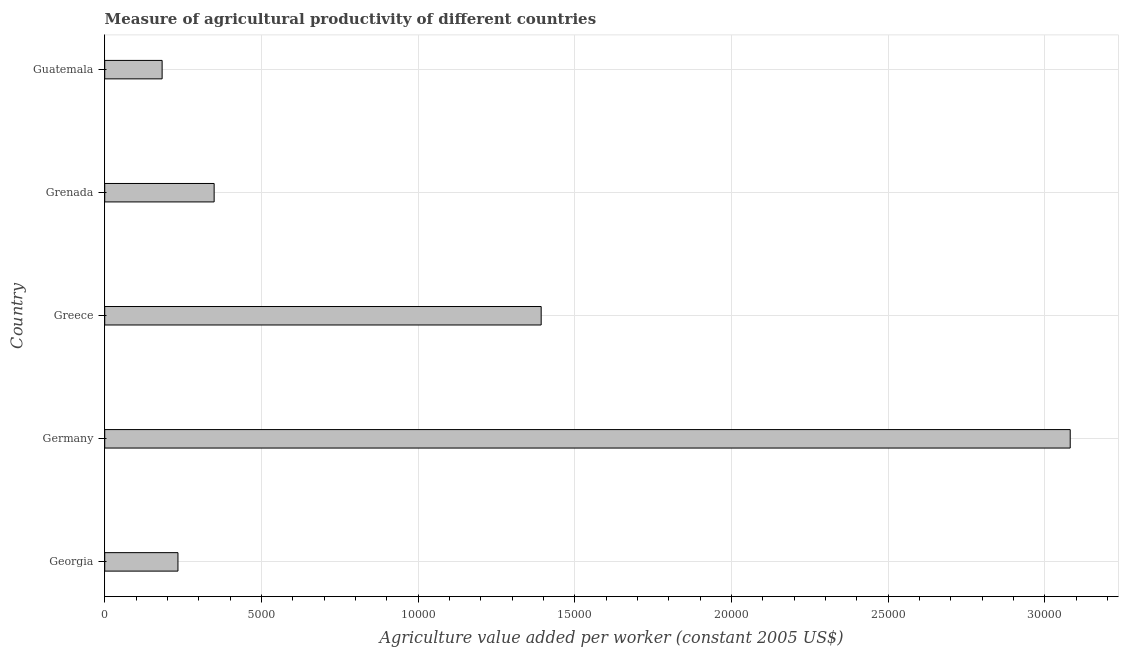Does the graph contain any zero values?
Offer a terse response. No. Does the graph contain grids?
Provide a succinct answer. Yes. What is the title of the graph?
Keep it short and to the point. Measure of agricultural productivity of different countries. What is the label or title of the X-axis?
Offer a terse response. Agriculture value added per worker (constant 2005 US$). What is the agriculture value added per worker in Greece?
Your response must be concise. 1.39e+04. Across all countries, what is the maximum agriculture value added per worker?
Your response must be concise. 3.08e+04. Across all countries, what is the minimum agriculture value added per worker?
Your response must be concise. 1832.24. In which country was the agriculture value added per worker maximum?
Give a very brief answer. Germany. In which country was the agriculture value added per worker minimum?
Your answer should be compact. Guatemala. What is the sum of the agriculture value added per worker?
Offer a terse response. 5.24e+04. What is the difference between the agriculture value added per worker in Georgia and Guatemala?
Your answer should be very brief. 504.81. What is the average agriculture value added per worker per country?
Ensure brevity in your answer.  1.05e+04. What is the median agriculture value added per worker?
Offer a terse response. 3492.41. What is the ratio of the agriculture value added per worker in Georgia to that in Germany?
Offer a very short reply. 0.08. Is the difference between the agriculture value added per worker in Greece and Guatemala greater than the difference between any two countries?
Your response must be concise. No. What is the difference between the highest and the second highest agriculture value added per worker?
Your response must be concise. 1.69e+04. What is the difference between the highest and the lowest agriculture value added per worker?
Ensure brevity in your answer.  2.90e+04. What is the difference between two consecutive major ticks on the X-axis?
Your response must be concise. 5000. Are the values on the major ticks of X-axis written in scientific E-notation?
Offer a terse response. No. What is the Agriculture value added per worker (constant 2005 US$) in Georgia?
Offer a terse response. 2337.06. What is the Agriculture value added per worker (constant 2005 US$) of Germany?
Make the answer very short. 3.08e+04. What is the Agriculture value added per worker (constant 2005 US$) of Greece?
Keep it short and to the point. 1.39e+04. What is the Agriculture value added per worker (constant 2005 US$) in Grenada?
Ensure brevity in your answer.  3492.41. What is the Agriculture value added per worker (constant 2005 US$) of Guatemala?
Your response must be concise. 1832.24. What is the difference between the Agriculture value added per worker (constant 2005 US$) in Georgia and Germany?
Your answer should be compact. -2.85e+04. What is the difference between the Agriculture value added per worker (constant 2005 US$) in Georgia and Greece?
Offer a terse response. -1.16e+04. What is the difference between the Agriculture value added per worker (constant 2005 US$) in Georgia and Grenada?
Offer a terse response. -1155.35. What is the difference between the Agriculture value added per worker (constant 2005 US$) in Georgia and Guatemala?
Your answer should be very brief. 504.81. What is the difference between the Agriculture value added per worker (constant 2005 US$) in Germany and Greece?
Your answer should be very brief. 1.69e+04. What is the difference between the Agriculture value added per worker (constant 2005 US$) in Germany and Grenada?
Your response must be concise. 2.73e+04. What is the difference between the Agriculture value added per worker (constant 2005 US$) in Germany and Guatemala?
Your response must be concise. 2.90e+04. What is the difference between the Agriculture value added per worker (constant 2005 US$) in Greece and Grenada?
Offer a terse response. 1.04e+04. What is the difference between the Agriculture value added per worker (constant 2005 US$) in Greece and Guatemala?
Offer a terse response. 1.21e+04. What is the difference between the Agriculture value added per worker (constant 2005 US$) in Grenada and Guatemala?
Your answer should be compact. 1660.16. What is the ratio of the Agriculture value added per worker (constant 2005 US$) in Georgia to that in Germany?
Your response must be concise. 0.08. What is the ratio of the Agriculture value added per worker (constant 2005 US$) in Georgia to that in Greece?
Your answer should be compact. 0.17. What is the ratio of the Agriculture value added per worker (constant 2005 US$) in Georgia to that in Grenada?
Your answer should be compact. 0.67. What is the ratio of the Agriculture value added per worker (constant 2005 US$) in Georgia to that in Guatemala?
Offer a very short reply. 1.28. What is the ratio of the Agriculture value added per worker (constant 2005 US$) in Germany to that in Greece?
Keep it short and to the point. 2.21. What is the ratio of the Agriculture value added per worker (constant 2005 US$) in Germany to that in Grenada?
Your answer should be compact. 8.82. What is the ratio of the Agriculture value added per worker (constant 2005 US$) in Germany to that in Guatemala?
Your answer should be compact. 16.82. What is the ratio of the Agriculture value added per worker (constant 2005 US$) in Greece to that in Grenada?
Offer a very short reply. 3.99. What is the ratio of the Agriculture value added per worker (constant 2005 US$) in Greece to that in Guatemala?
Provide a short and direct response. 7.6. What is the ratio of the Agriculture value added per worker (constant 2005 US$) in Grenada to that in Guatemala?
Provide a succinct answer. 1.91. 